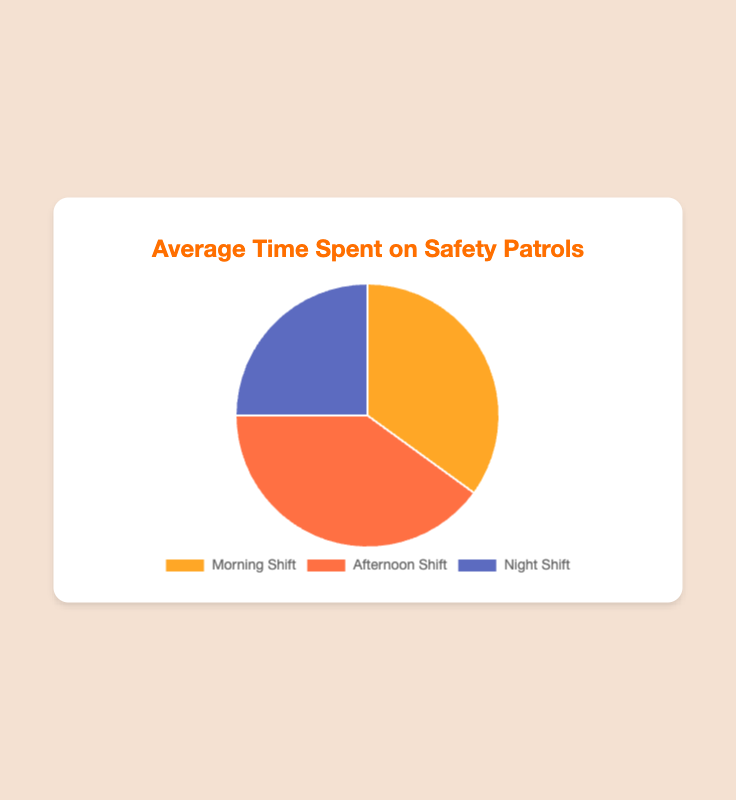What percentage of the total time is spent on the Afternoon Shift? To find the percentage spent on the Afternoon Shift, divide the time spent on the Afternoon Shift by the total time (3.5+4+2.5=10 hours) and multiply by 100. ((4/10)*100 = 40%)
Answer: 40% Which shift has the highest average time spent on safety patrols? Compare the average time spent on each shift: 3.5 hours for the Morning Shift, 4 hours for the Afternoon Shift, and 2.5 hours for the Night Shift. The Afternoon Shift has the highest value.
Answer: Afternoon Shift What is the sum of the average time spent on the Morning and Night Shifts? Add the average time spent on the Morning Shift (3.5 hours) and the Night Shift (2.5 hours). 3.5 + 2.5 = 6
Answer: 6 hours Is the time spent on the Night Shift more than half of the time spent on the Afternoon Shift? Compare half of the time spent on the Afternoon Shift (4/2=2 hours) to the time spent on the Night Shift (2.5 hours). 2.5 is greater than 2.
Answer: Yes What is the difference in average time spent between the Morning Shift and the Night Shift? Subtract the time spent on the Night Shift (2.5 hours) from the time spent on the Morning Shift (3.5 hours). 3.5 - 2.5 = 1
Answer: 1 hour What fraction of the total time is spent on the Morning Shift? Divide the time spent on the Morning Shift by the total time. (3.5/10=0.35)
Answer: 0.35 Which two shifts combined have the exact same amount of time spent as the Afternoon Shift? Add the average time spent on each pair of shifts and compare: Morning (3.5) + Night (2.5) = 6, Morning (3.5) + Afternoon (4) = 7.5, Afternoon (4) + Night (2.5) = 6.5. No pairs equal exactly the Afternoon Shift's 4 hours.
Answer: None What is the ratio of time spent on the Afternoon Shift to the Night Shift? Divide the time spent on the Afternoon Shift by the time spent on the Night Shift. 4/2.5 = 1.6
Answer: 1.6 